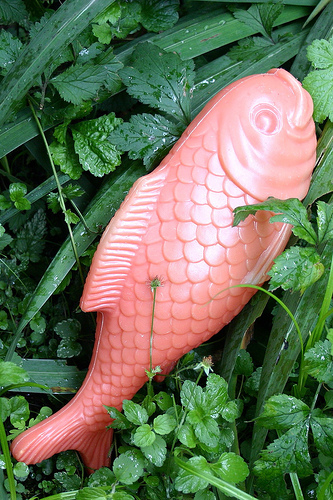<image>
Can you confirm if the grass is under the fish? Yes. The grass is positioned underneath the fish, with the fish above it in the vertical space. Is there a plant behind the fish? Yes. From this viewpoint, the plant is positioned behind the fish, with the fish partially or fully occluding the plant. 